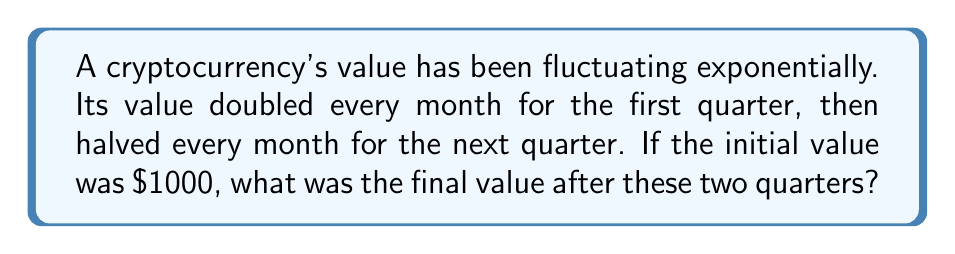Could you help me with this problem? Let's break this down step-by-step:

1) Initial value: $1000

2) First quarter (3 months):
   - Month 1: $1000 * 2 = $2000
   - Month 2: $2000 * 2 = $4000
   - Month 3: $4000 * 2 = $8000

   We can express this as: $1000 * 2^3 = $8000$

3) Second quarter (3 months):
   - Month 4: $8000 ÷ 2 = $4000
   - Month 5: $4000 ÷ 2 = $2000
   - Month 6: $2000 ÷ 2 = $1000

   We can express this as: $8000 * (1/2)^3 = $1000$

4) Mathematically, we can represent the entire process as:

   $$1000 * 2^3 * (1/2)^3$$

5) Simplify:
   $$1000 * \frac{2^3}{2^3} = 1000 * 1 = 1000$$

Therefore, after the two quarters of fluctuation, the value returns to $1000.
Answer: $1000 